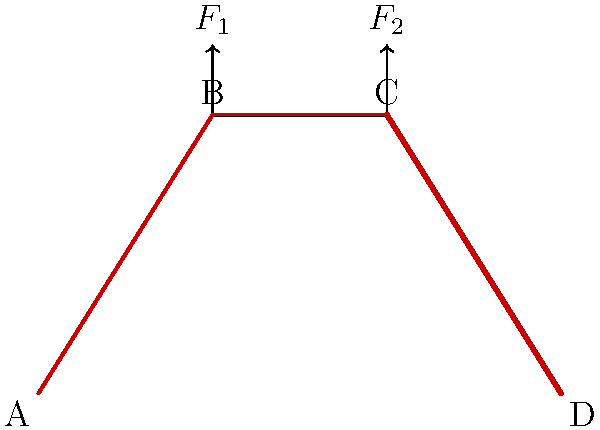As an innovative tech entrepreneur focusing on sustainable transportation, you're developing a new eco-friendly bicycle frame. The frame is subjected to two vertical forces $F_1$ and $F_2$ at points B and C, respectively. Given that the frame material has a yield strength of 250 MPa, what is the maximum allowable force $F_2$ if $F_1 = 800$ N and the cross-sectional area at point D is 200 mm²? Assume the stress distribution shown in the diagram and that the maximum stress occurs at point D. Let's approach this step-by-step:

1) First, we need to understand that the maximum stress occurs at point D, as stated in the question.

2) The yield strength of the material is 250 MPa. This is the maximum stress the material can withstand without permanent deformation. Therefore, the stress at point D must not exceed 250 MPa.

3) The stress at point D is caused by both forces $F_1$ and $F_2$. We need to find their combined effect.

4) Due to the geometry of the frame, we can assume that the vertical forces are transferred to point D as a combination of axial and bending stresses. However, for simplification, we'll consider only the axial component.

5) The axial force at D is approximately equal to $F_1 + F_2$.

6) The stress at D is given by:

   $$\sigma_D = \frac{F_1 + F_2}{A}$$

   where $A$ is the cross-sectional area at D.

7) We know that $\sigma_D$ must not exceed 250 MPa, $F_1 = 800$ N, and $A = 200$ mm² = $200 \times 10^{-6}$ m².

8) Substituting these values:

   $$250 \times 10^6 = \frac{800 + F_2}{200 \times 10^{-6}}$$

9) Solving for $F_2$:

   $$F_2 = (250 \times 10^6 \times 200 \times 10^{-6}) - 800 = 49,200 \text{ N}$$

Therefore, the maximum allowable force $F_2$ is approximately 49,200 N or 49.2 kN.
Answer: 49.2 kN 